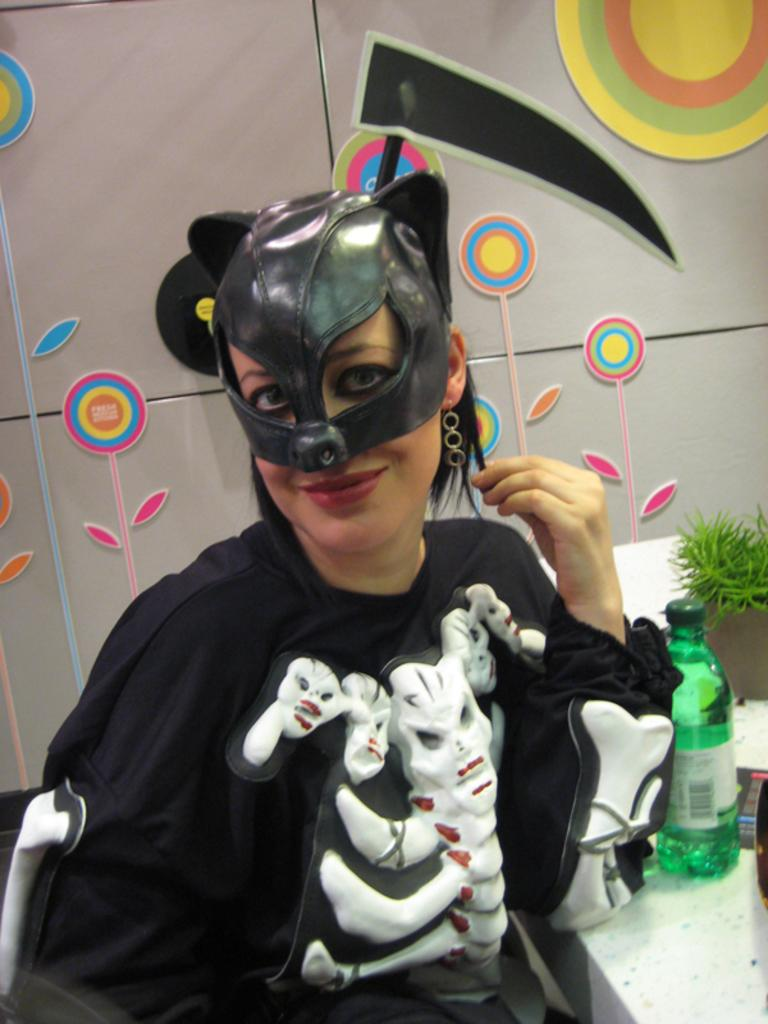Who is the main subject in the image? There is a woman in the image. What is the woman wearing? The woman is wearing a black fancy dress. What is the woman doing in the image? The woman is sitting. What is located beside the woman? There is a table beside the woman. What type of sweater is the woman wearing in the image? The woman is not wearing a sweater in the image; she is wearing a black fancy dress. How many passengers are visible in the image? There are no passengers visible in the image, as it only features a woman sitting beside a table. 